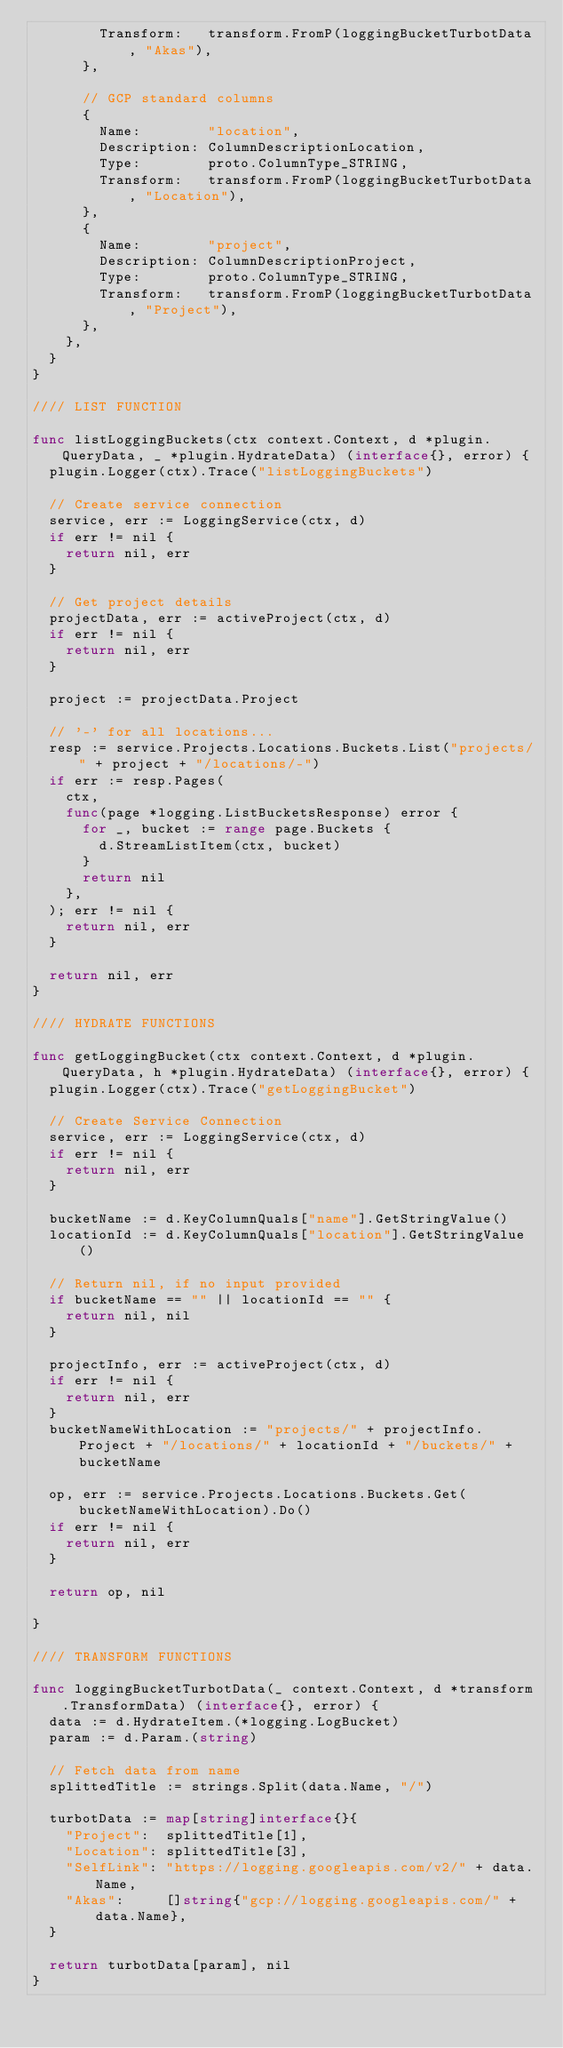<code> <loc_0><loc_0><loc_500><loc_500><_Go_>				Transform:   transform.FromP(loggingBucketTurbotData, "Akas"),
			},

			// GCP standard columns
			{
				Name:        "location",
				Description: ColumnDescriptionLocation,
				Type:        proto.ColumnType_STRING,
				Transform:   transform.FromP(loggingBucketTurbotData, "Location"),
			},
			{
				Name:        "project",
				Description: ColumnDescriptionProject,
				Type:        proto.ColumnType_STRING,
				Transform:   transform.FromP(loggingBucketTurbotData, "Project"),
			},
		},
	}
}

//// LIST FUNCTION

func listLoggingBuckets(ctx context.Context, d *plugin.QueryData, _ *plugin.HydrateData) (interface{}, error) {
	plugin.Logger(ctx).Trace("listLoggingBuckets")

	// Create service connection
	service, err := LoggingService(ctx, d)
	if err != nil {
		return nil, err
	}

	// Get project details
	projectData, err := activeProject(ctx, d)
	if err != nil {
		return nil, err
	}

	project := projectData.Project

	// '-' for all locations...
	resp := service.Projects.Locations.Buckets.List("projects/" + project + "/locations/-")
	if err := resp.Pages(
		ctx,
		func(page *logging.ListBucketsResponse) error {
			for _, bucket := range page.Buckets {
				d.StreamListItem(ctx, bucket)
			}
			return nil
		},
	); err != nil {
		return nil, err
	}

	return nil, err
}

//// HYDRATE FUNCTIONS

func getLoggingBucket(ctx context.Context, d *plugin.QueryData, h *plugin.HydrateData) (interface{}, error) {
	plugin.Logger(ctx).Trace("getLoggingBucket")

	// Create Service Connection
	service, err := LoggingService(ctx, d)
	if err != nil {
		return nil, err
	}

	bucketName := d.KeyColumnQuals["name"].GetStringValue()
	locationId := d.KeyColumnQuals["location"].GetStringValue()

	// Return nil, if no input provided
	if bucketName == "" || locationId == "" {
		return nil, nil
	}

	projectInfo, err := activeProject(ctx, d)
	if err != nil {
		return nil, err
	}
	bucketNameWithLocation := "projects/" + projectInfo.Project + "/locations/" + locationId + "/buckets/" + bucketName

	op, err := service.Projects.Locations.Buckets.Get(bucketNameWithLocation).Do()
	if err != nil {
		return nil, err
	}

	return op, nil

}

//// TRANSFORM FUNCTIONS

func loggingBucketTurbotData(_ context.Context, d *transform.TransformData) (interface{}, error) {
	data := d.HydrateItem.(*logging.LogBucket)
	param := d.Param.(string)

	// Fetch data from name
	splittedTitle := strings.Split(data.Name, "/")

	turbotData := map[string]interface{}{
		"Project":  splittedTitle[1],
		"Location": splittedTitle[3],
		"SelfLink": "https://logging.googleapis.com/v2/" + data.Name,
		"Akas":     []string{"gcp://logging.googleapis.com/" + data.Name},
	}

	return turbotData[param], nil
}
</code> 